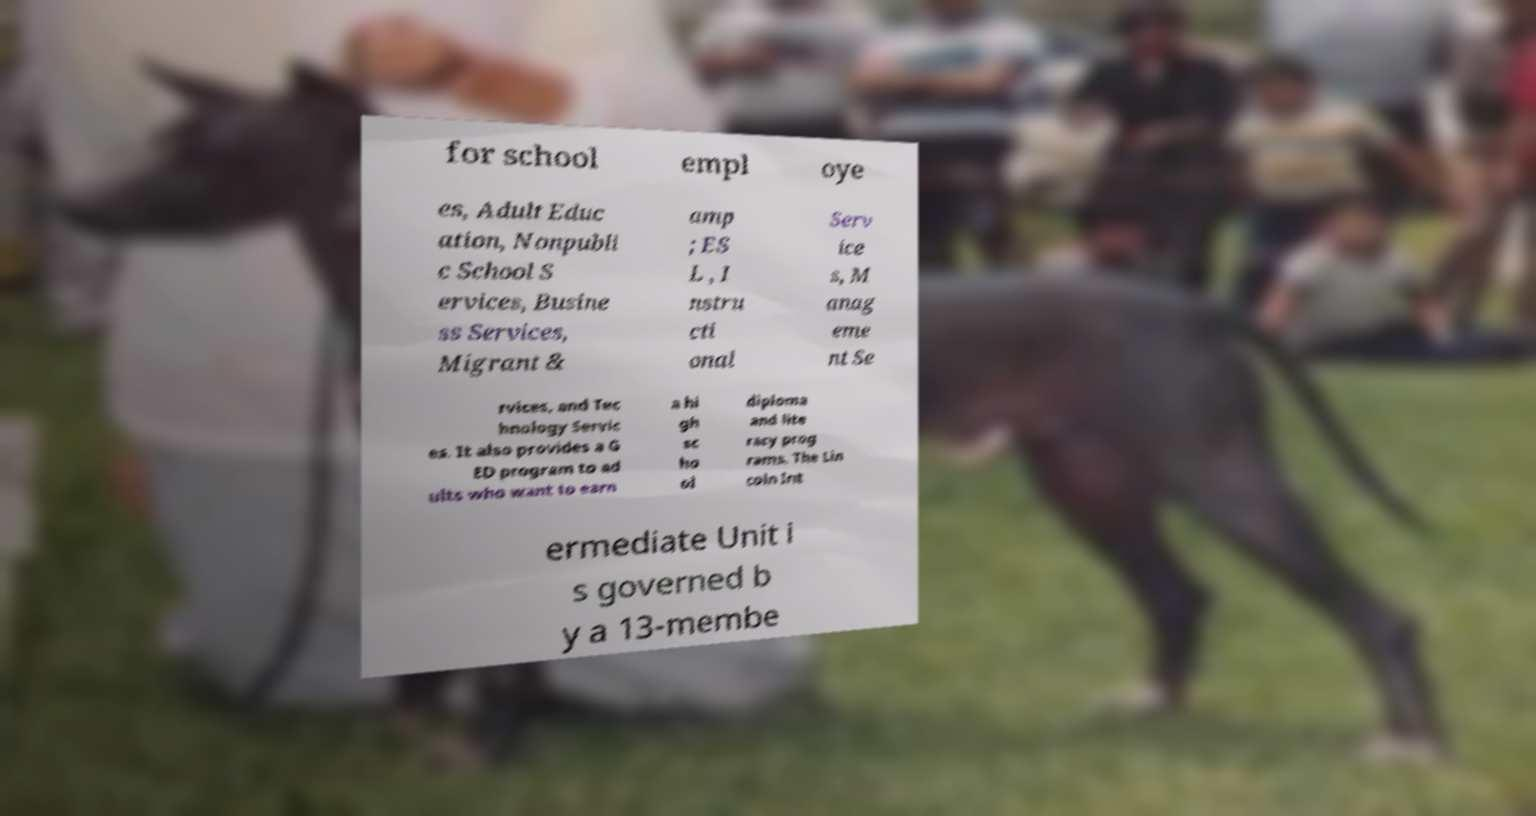For documentation purposes, I need the text within this image transcribed. Could you provide that? for school empl oye es, Adult Educ ation, Nonpubli c School S ervices, Busine ss Services, Migrant & amp ; ES L , I nstru cti onal Serv ice s, M anag eme nt Se rvices, and Tec hnology Servic es. It also provides a G ED program to ad ults who want to earn a hi gh sc ho ol diploma and lite racy prog rams. The Lin coln Int ermediate Unit i s governed b y a 13-membe 